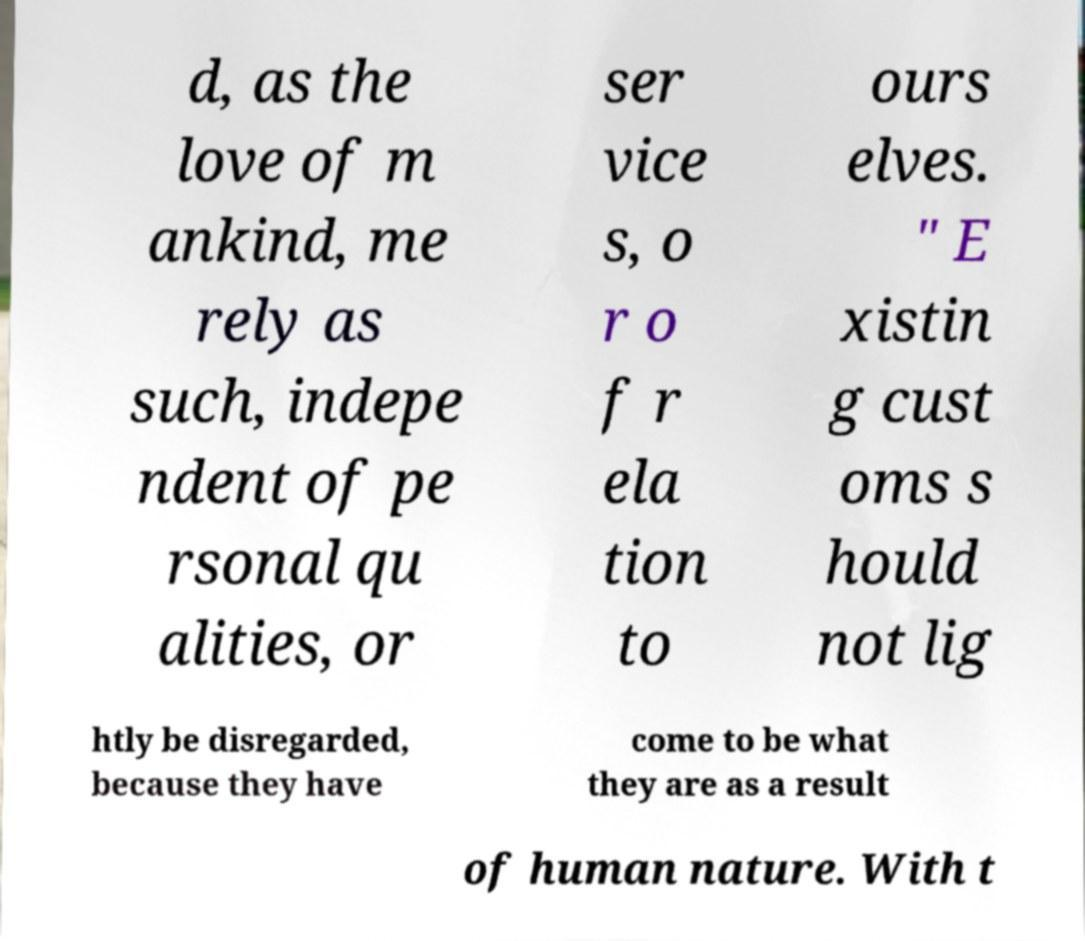There's text embedded in this image that I need extracted. Can you transcribe it verbatim? d, as the love of m ankind, me rely as such, indepe ndent of pe rsonal qu alities, or ser vice s, o r o f r ela tion to ours elves. " E xistin g cust oms s hould not lig htly be disregarded, because they have come to be what they are as a result of human nature. With t 